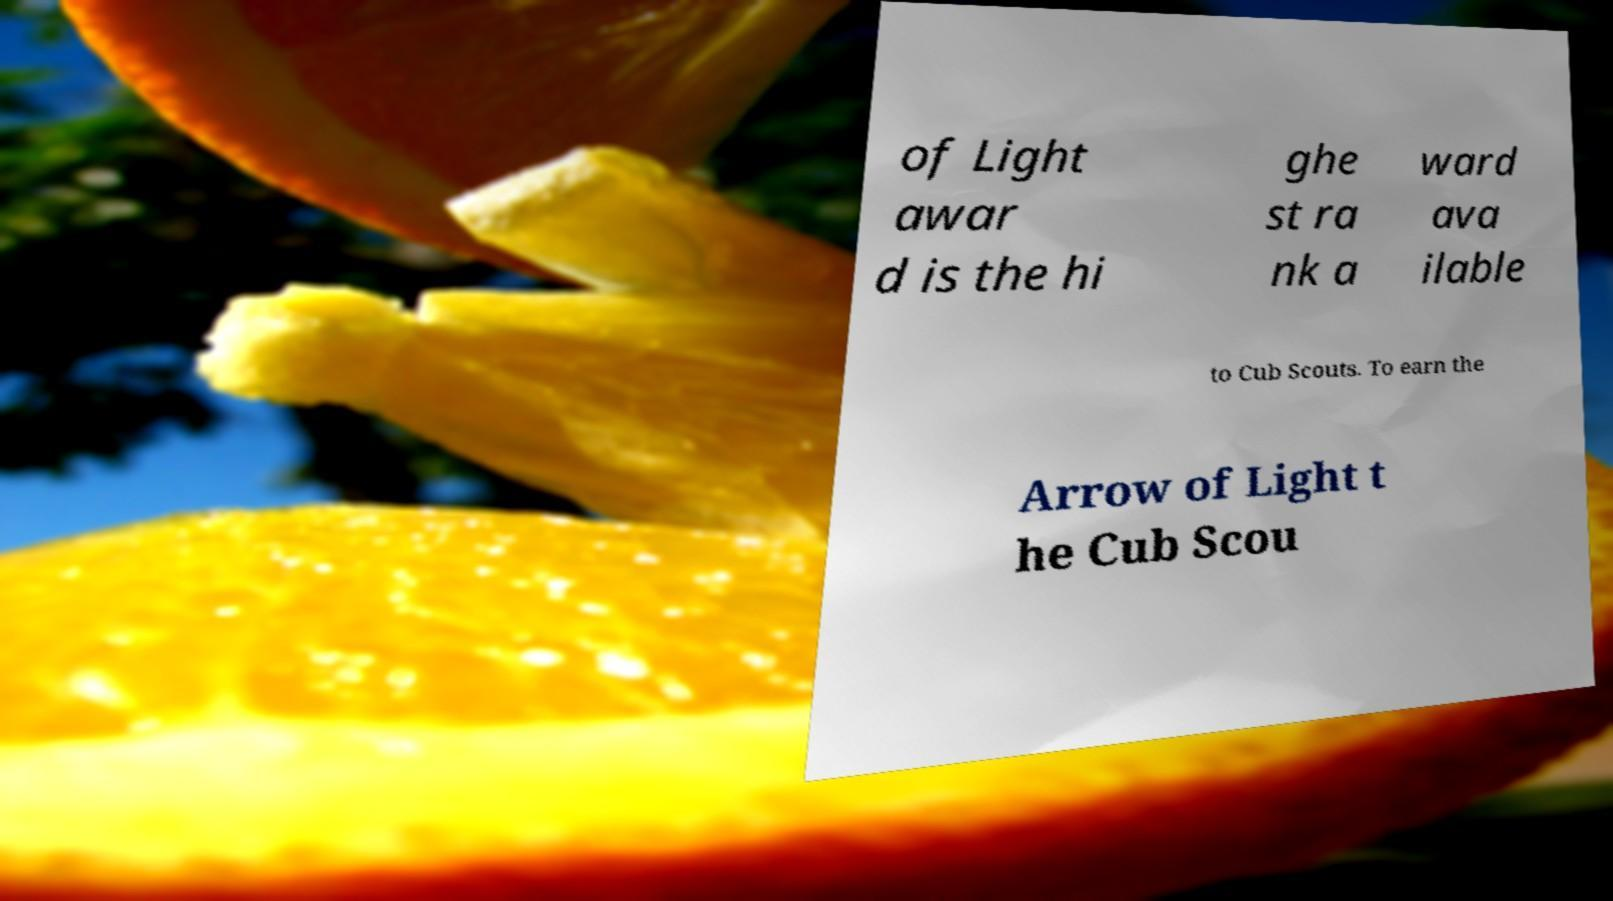Could you extract and type out the text from this image? of Light awar d is the hi ghe st ra nk a ward ava ilable to Cub Scouts. To earn the Arrow of Light t he Cub Scou 